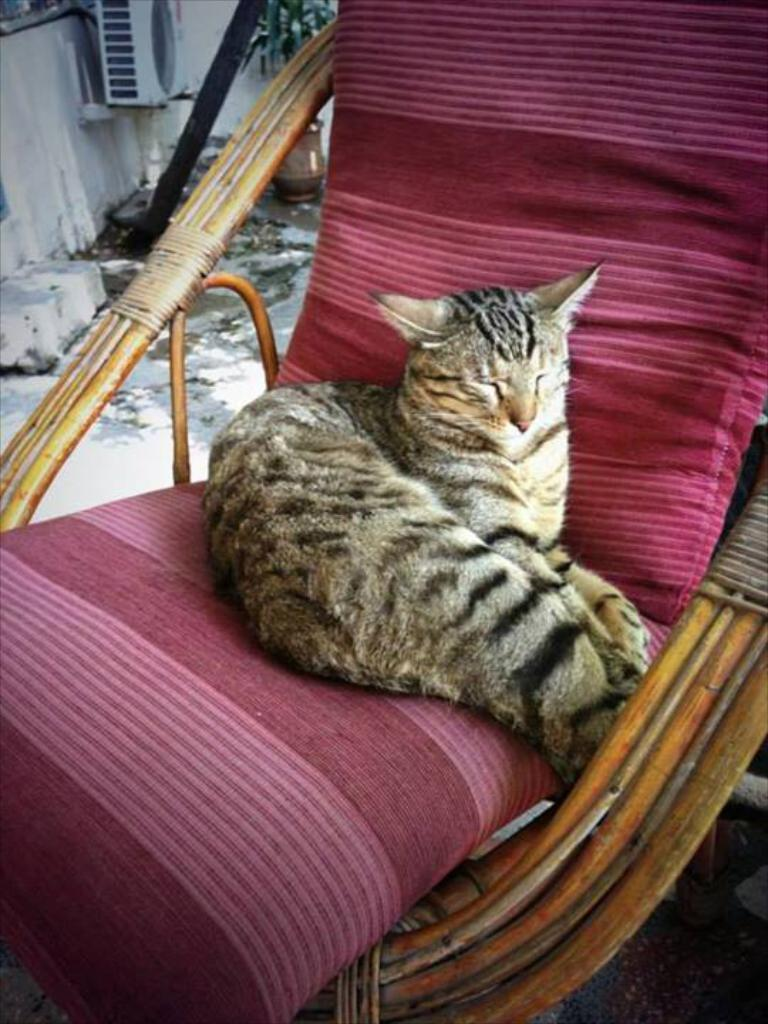What animal is sitting on the chair in the image? There is a cat on the chair in the image. What type of vegetation is present in the image? There is a plant in the image. What part of the room can be seen in the image? The floor is visible in the image. What architectural feature is present in the image? There is a wall in the image. How does the cat taste the mitten in the image? There is no mitten present in the image, so the cat cannot taste it. 